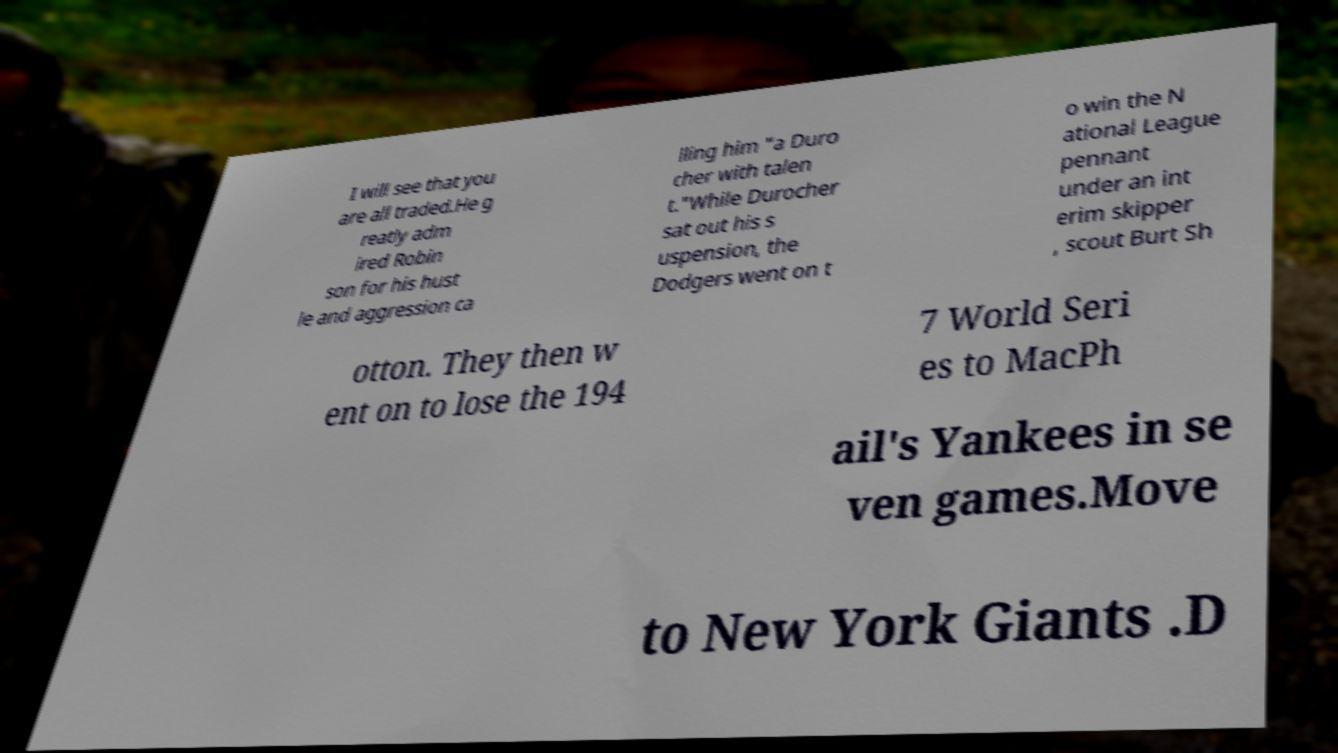There's text embedded in this image that I need extracted. Can you transcribe it verbatim? I will see that you are all traded.He g reatly adm ired Robin son for his hust le and aggression ca lling him "a Duro cher with talen t."While Durocher sat out his s uspension, the Dodgers went on t o win the N ational League pennant under an int erim skipper , scout Burt Sh otton. They then w ent on to lose the 194 7 World Seri es to MacPh ail's Yankees in se ven games.Move to New York Giants .D 